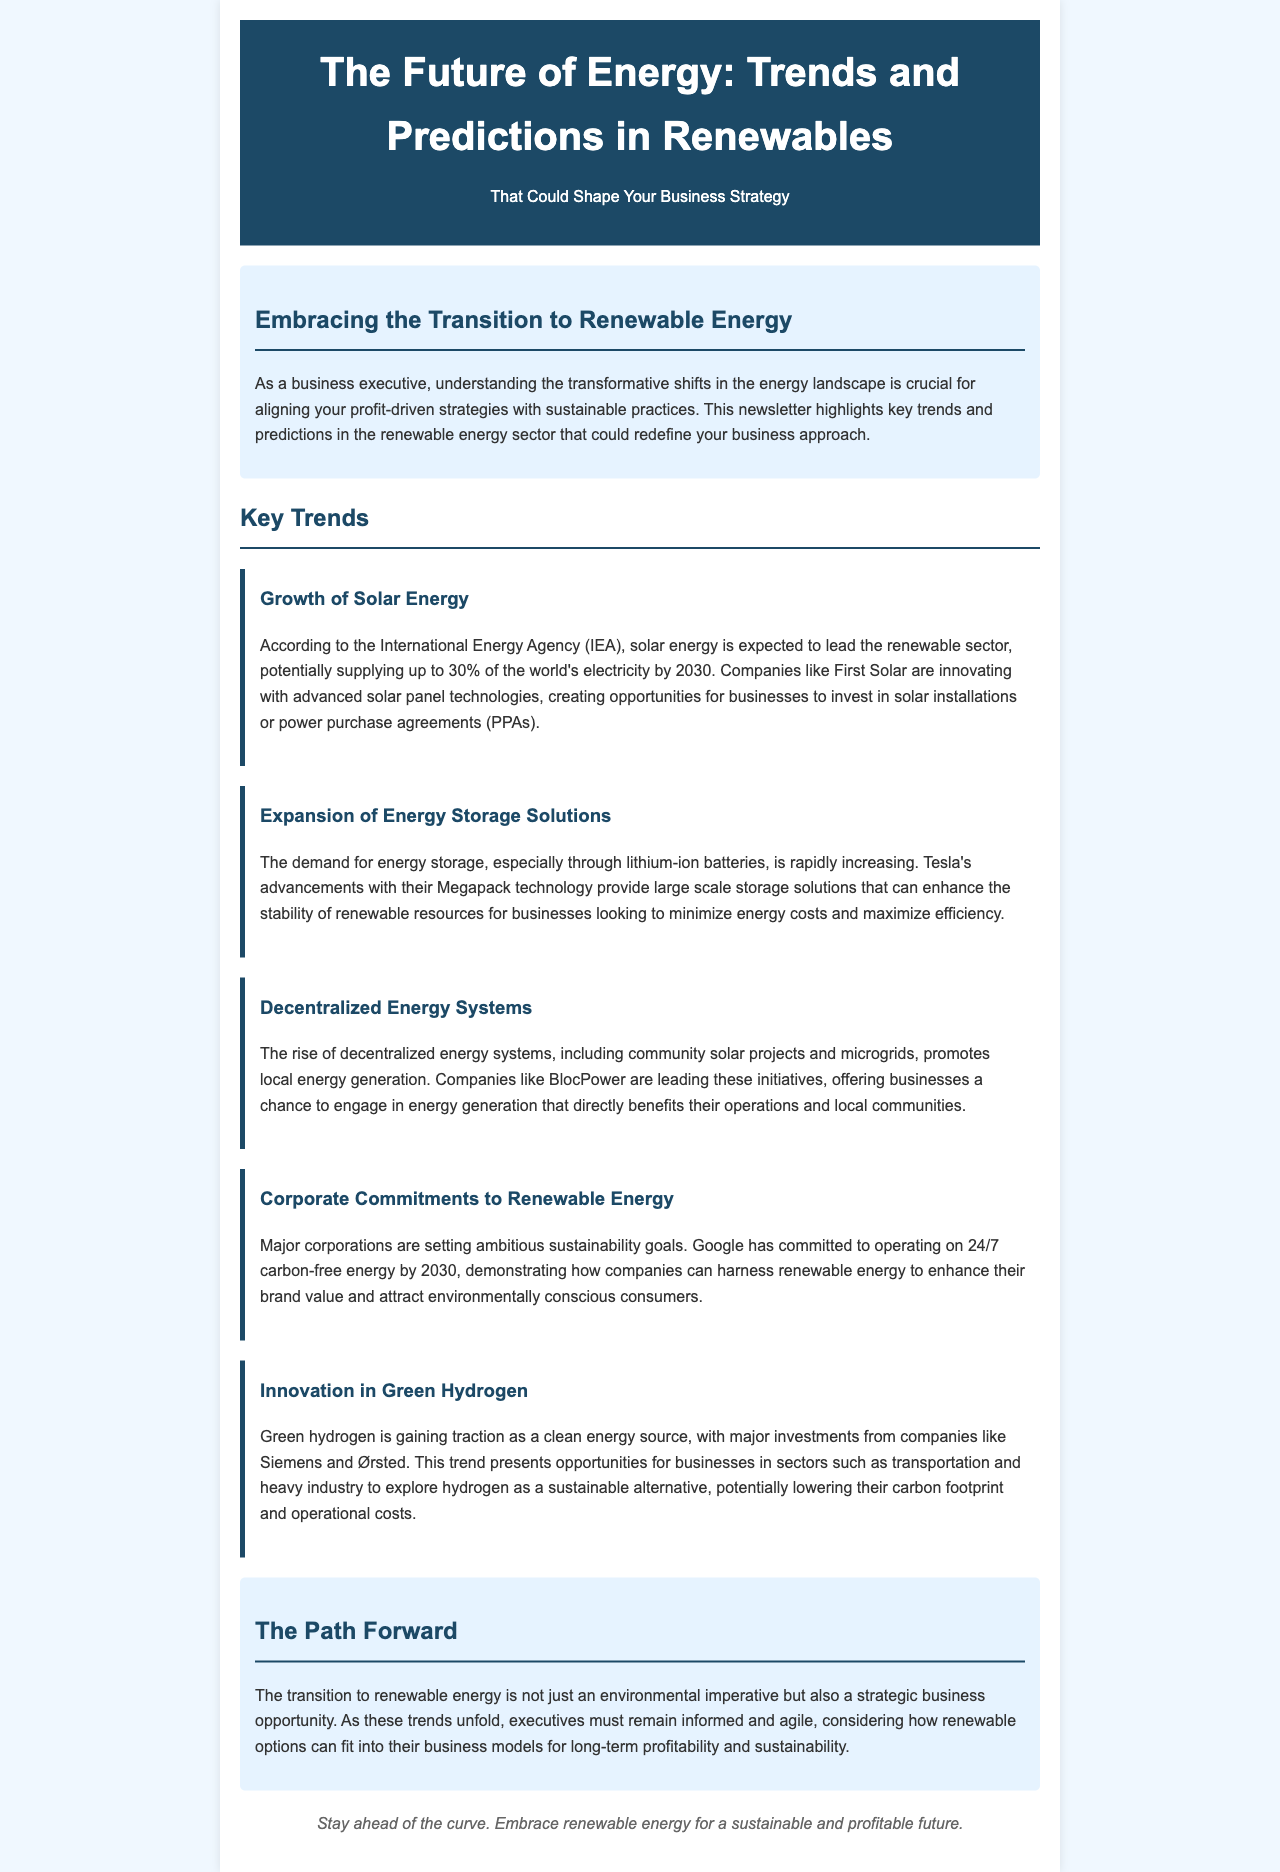what percentage of the world's electricity is solar energy expected to supply by 2030? According to the document, solar energy is expected to supply up to 30% of the world's electricity by 2030.
Answer: 30% who is innovating with advanced solar panel technologies? The document mentions that First Solar is innovating with advanced solar panel technologies.
Answer: First Solar what technology is Tesla advancing for energy storage solutions? The document states that Tesla is advancing their Megapack technology for energy storage solutions.
Answer: Megapack which company has committed to operating on 24/7 carbon-free energy by 2030? The document indicates that Google has committed to operating on 24/7 carbon-free energy by 2030.
Answer: Google what type of energy does green hydrogen represent? Green hydrogen represents a clean energy source as mentioned in the document.
Answer: clean energy source how can companies benefit from decentralized energy systems? The document suggests that decentralized energy systems allow businesses to engage in energy generation that benefits their operations and local communities.
Answer: energy generation benefits what must executives consider for long-term profitability according to the conclusion? The conclusion emphasizes that executives must consider how renewable options can fit into their business models for long-term profitability and sustainability.
Answer: renewable options what is the purpose of this newsletter? The newsletter aims to highlight key trends and predictions in the renewable energy sector that could redefine business approaches.
Answer: highlight key trends who is leading initiatives in decentralized energy systems? The document notes that companies like BlocPower are leading initiatives in decentralized energy systems.
Answer: BlocPower 